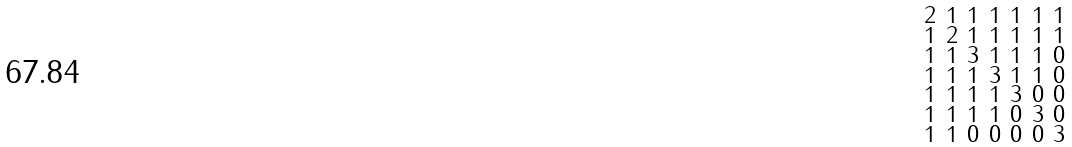<formula> <loc_0><loc_0><loc_500><loc_500>\begin{smallmatrix} 2 & 1 & 1 & 1 & 1 & 1 & 1 \\ 1 & 2 & 1 & 1 & 1 & 1 & 1 \\ 1 & 1 & 3 & 1 & 1 & 1 & 0 \\ 1 & 1 & 1 & 3 & 1 & 1 & 0 \\ 1 & 1 & 1 & 1 & 3 & 0 & 0 \\ 1 & 1 & 1 & 1 & 0 & 3 & 0 \\ 1 & 1 & 0 & 0 & 0 & 0 & 3 \end{smallmatrix}</formula> 